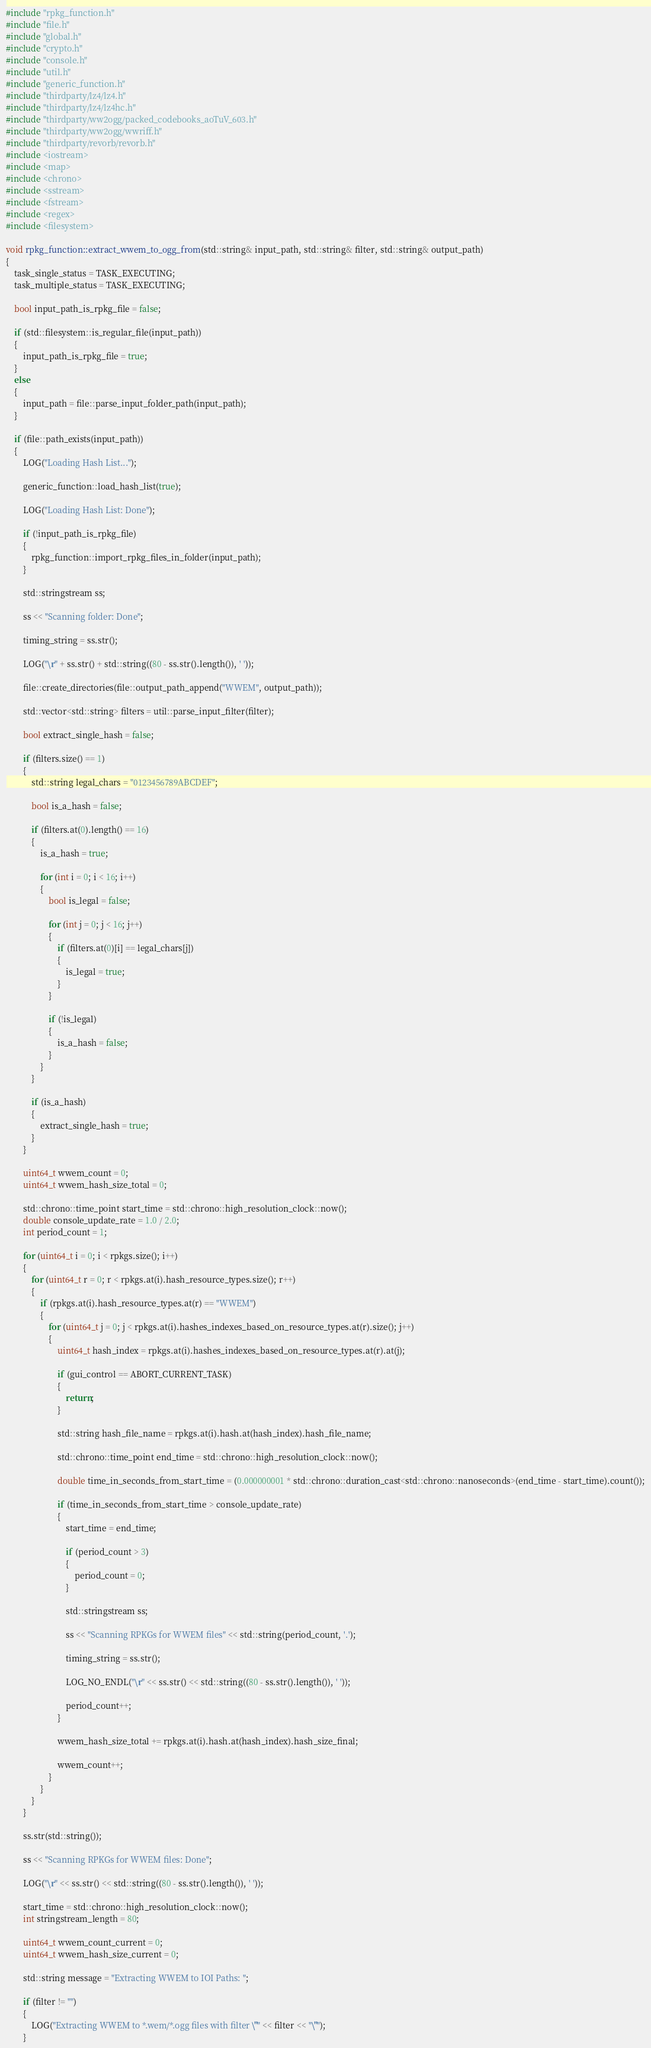Convert code to text. <code><loc_0><loc_0><loc_500><loc_500><_C++_>#include "rpkg_function.h"
#include "file.h"
#include "global.h"
#include "crypto.h"
#include "console.h"
#include "util.h"
#include "generic_function.h"
#include "thirdparty/lz4/lz4.h"
#include "thirdparty/lz4/lz4hc.h"
#include "thirdparty/ww2ogg/packed_codebooks_aoTuV_603.h"
#include "thirdparty/ww2ogg/wwriff.h"
#include "thirdparty/revorb/revorb.h"
#include <iostream>
#include <map>
#include <chrono>
#include <sstream>
#include <fstream>
#include <regex>
#include <filesystem>

void rpkg_function::extract_wwem_to_ogg_from(std::string& input_path, std::string& filter, std::string& output_path)
{
    task_single_status = TASK_EXECUTING;
    task_multiple_status = TASK_EXECUTING;

    bool input_path_is_rpkg_file = false;

    if (std::filesystem::is_regular_file(input_path))
    {
        input_path_is_rpkg_file = true;
    }
    else
    {
        input_path = file::parse_input_folder_path(input_path);
    }

    if (file::path_exists(input_path))
    {
        LOG("Loading Hash List...");

        generic_function::load_hash_list(true);

        LOG("Loading Hash List: Done");

        if (!input_path_is_rpkg_file)
        {
            rpkg_function::import_rpkg_files_in_folder(input_path);
        }

        std::stringstream ss;

        ss << "Scanning folder: Done";

        timing_string = ss.str();

        LOG("\r" + ss.str() + std::string((80 - ss.str().length()), ' '));

        file::create_directories(file::output_path_append("WWEM", output_path));

        std::vector<std::string> filters = util::parse_input_filter(filter);

        bool extract_single_hash = false;

        if (filters.size() == 1)
        {
            std::string legal_chars = "0123456789ABCDEF";

            bool is_a_hash = false;

            if (filters.at(0).length() == 16)
            {
                is_a_hash = true;

                for (int i = 0; i < 16; i++)
                {
                    bool is_legal = false;

                    for (int j = 0; j < 16; j++)
                    {
                        if (filters.at(0)[i] == legal_chars[j])
                        {
                            is_legal = true;
                        }
                    }

                    if (!is_legal)
                    {
                        is_a_hash = false;
                    }
                }
            }

            if (is_a_hash)
            {
                extract_single_hash = true;
            }
        }

        uint64_t wwem_count = 0;
        uint64_t wwem_hash_size_total = 0;

        std::chrono::time_point start_time = std::chrono::high_resolution_clock::now();
        double console_update_rate = 1.0 / 2.0;
        int period_count = 1;

        for (uint64_t i = 0; i < rpkgs.size(); i++)
        {
            for (uint64_t r = 0; r < rpkgs.at(i).hash_resource_types.size(); r++)
            {
                if (rpkgs.at(i).hash_resource_types.at(r) == "WWEM")
                {
                    for (uint64_t j = 0; j < rpkgs.at(i).hashes_indexes_based_on_resource_types.at(r).size(); j++)
                    {
                        uint64_t hash_index = rpkgs.at(i).hashes_indexes_based_on_resource_types.at(r).at(j);

                        if (gui_control == ABORT_CURRENT_TASK)
                        {
                            return;
                        }

                        std::string hash_file_name = rpkgs.at(i).hash.at(hash_index).hash_file_name;

                        std::chrono::time_point end_time = std::chrono::high_resolution_clock::now();

                        double time_in_seconds_from_start_time = (0.000000001 * std::chrono::duration_cast<std::chrono::nanoseconds>(end_time - start_time).count());

                        if (time_in_seconds_from_start_time > console_update_rate)
                        {
                            start_time = end_time;

                            if (period_count > 3)
                            {
                                period_count = 0;
                            }

                            std::stringstream ss;

                            ss << "Scanning RPKGs for WWEM files" << std::string(period_count, '.');

                            timing_string = ss.str();

                            LOG_NO_ENDL("\r" << ss.str() << std::string((80 - ss.str().length()), ' '));

                            period_count++;
                        }

                        wwem_hash_size_total += rpkgs.at(i).hash.at(hash_index).hash_size_final;

                        wwem_count++;
                    }
                }
            }
        }

        ss.str(std::string());

        ss << "Scanning RPKGs for WWEM files: Done";

        LOG("\r" << ss.str() << std::string((80 - ss.str().length()), ' '));

        start_time = std::chrono::high_resolution_clock::now();
        int stringstream_length = 80;

        uint64_t wwem_count_current = 0;
        uint64_t wwem_hash_size_current = 0;

        std::string message = "Extracting WWEM to IOI Paths: ";

        if (filter != "")
        {
            LOG("Extracting WWEM to *.wem/*.ogg files with filter \"" << filter << "\"");
        }
</code> 